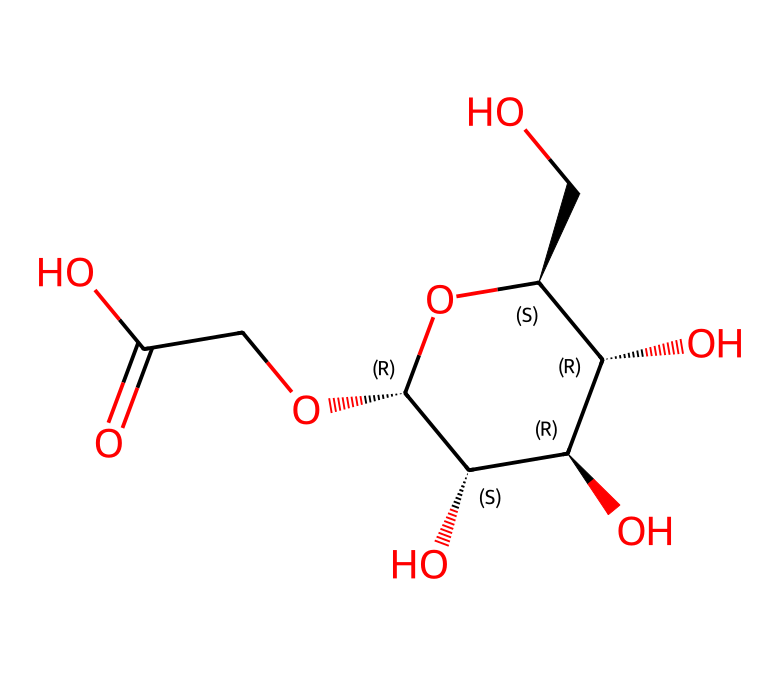What is the molecular formula of carboxymethyl cellulose? By analyzing the SMILES representation, we can identify the elements present (C, H, O) and count the number of each atom. The counts reveal that the molecular formula is C8H14O7.
Answer: C8H14O7 How many distinct types of functional groups are present in carboxymethyl cellulose? Examining the SMILES notation shows the presence of hydroxyl groups (-OH) and a carboxyl group (-COOH), making a total of two distinct types of functional groups.
Answer: 2 Does carboxymethyl cellulose contain any chiral centers? The SMILES structure reveals asymmetric carbon atoms (indicated by the '@' symbols), indicating the presence of chiral centers in the molecule.
Answer: Yes What property of carboxymethyl cellulose gives it its Non-Newtonian behavior? The hydroxyl functional groups in the structure contribute to the molecular interactions that create the Non-Newtonian behavior, allowing it to change viscosity under stress.
Answer: Viscosity How does the presence of carboxyl groups affect the solubility of carboxymethyl cellulose in water? The carboxyl groups are polar and can form hydrogen bonds with water molecules, which increases solubility in water due to enhanced interactions.
Answer: Increases solubility What type of intermolecular forces are significant in carboxymethyl cellulose? The presence of hydroxyl and carboxyl groups introduces hydrogen bonding as the dominant intermolecular force affecting the structure and behavior of the liquid.
Answer: Hydrogen bonding 